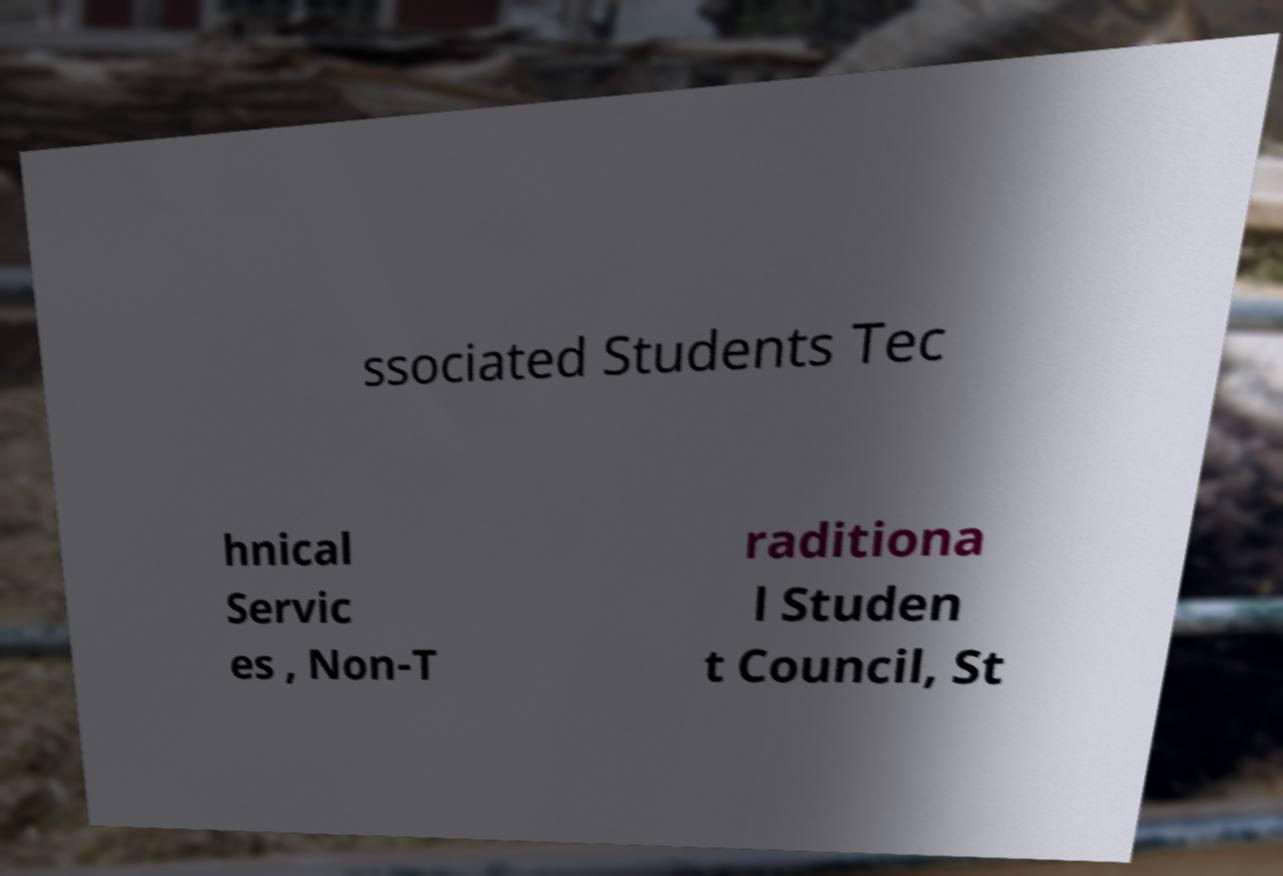I need the written content from this picture converted into text. Can you do that? ssociated Students Tec hnical Servic es , Non-T raditiona l Studen t Council, St 